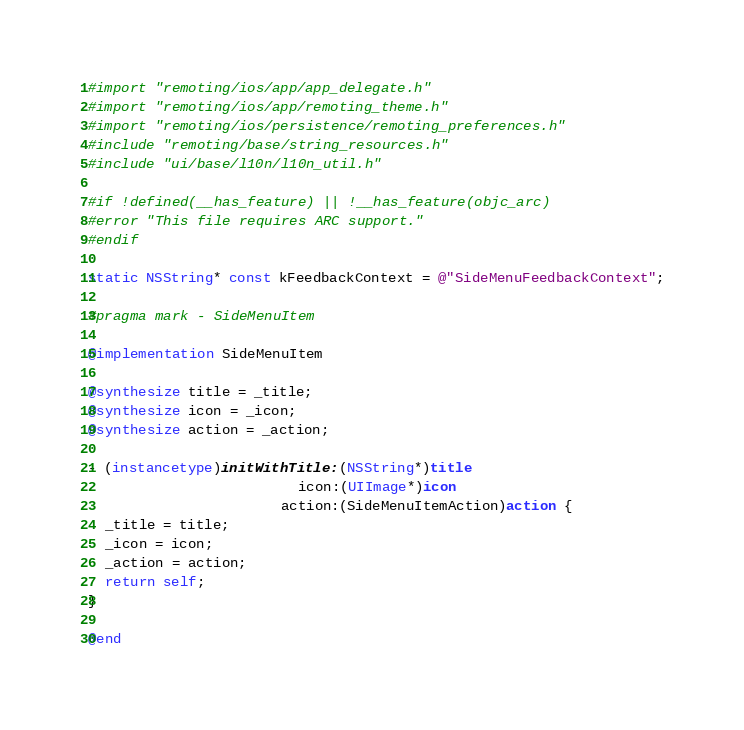Convert code to text. <code><loc_0><loc_0><loc_500><loc_500><_ObjectiveC_>#import "remoting/ios/app/app_delegate.h"
#import "remoting/ios/app/remoting_theme.h"
#import "remoting/ios/persistence/remoting_preferences.h"
#include "remoting/base/string_resources.h"
#include "ui/base/l10n/l10n_util.h"

#if !defined(__has_feature) || !__has_feature(objc_arc)
#error "This file requires ARC support."
#endif

static NSString* const kFeedbackContext = @"SideMenuFeedbackContext";

#pragma mark - SideMenuItem

@implementation SideMenuItem

@synthesize title = _title;
@synthesize icon = _icon;
@synthesize action = _action;

- (instancetype)initWithTitle:(NSString*)title
                         icon:(UIImage*)icon
                       action:(SideMenuItemAction)action {
  _title = title;
  _icon = icon;
  _action = action;
  return self;
}

@end
</code> 